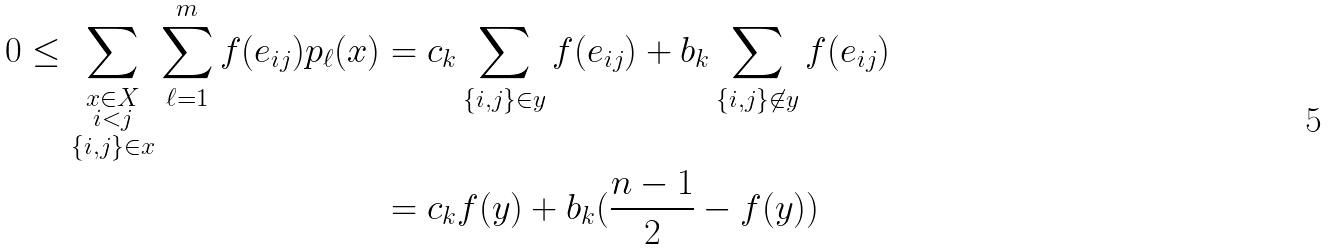<formula> <loc_0><loc_0><loc_500><loc_500>0 \leq \sum _ { \substack { x \in X \\ i < j \\ \{ i , j \} \in x } } \sum _ { \ell = 1 } ^ { m } f ( e _ { i j } ) p _ { \ell } ( x ) & = c _ { k } \sum _ { \{ i , j \} \in y } f ( e _ { i j } ) + b _ { k } \sum _ { \{ i , j \} \not \in y } f ( e _ { i j } ) \\ & = c _ { k } f ( y ) + b _ { k } ( \frac { n - 1 } { 2 } - f ( y ) )</formula> 